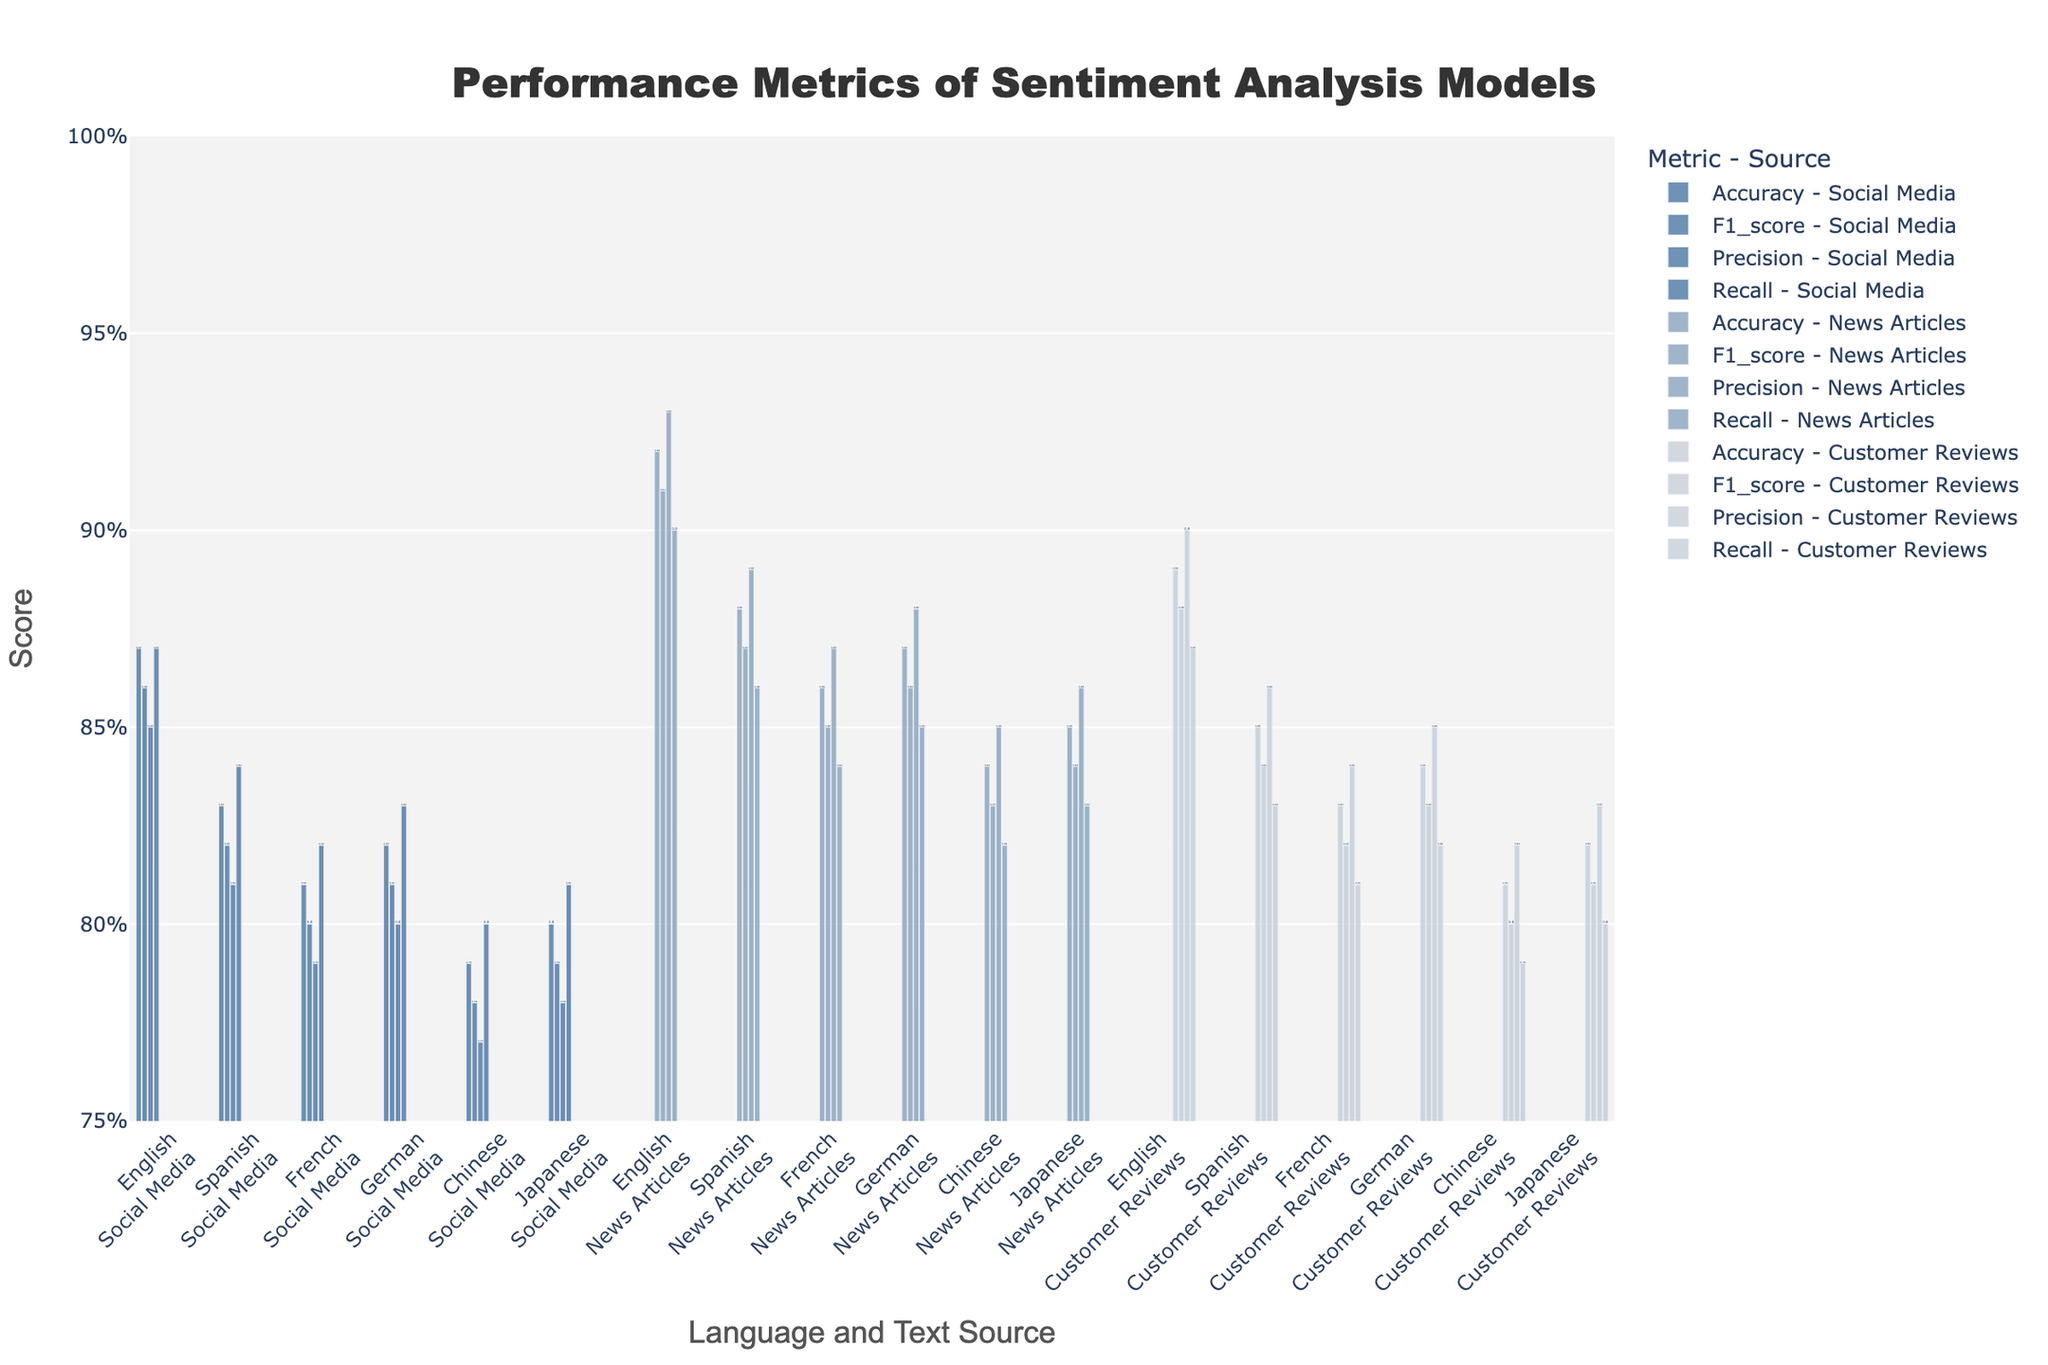Which language and text source combination has the highest accuracy? First, look for the highest values on the accuracy metric bars and then identify the corresponding language and text source. The highest bar corresponds to English, News Articles.
Answer: English, News Articles Compare the performance of sentiment analysis models in terms of F1_score across News Articles for English and Spanish. Which is higher? Focus on the F1_score bars for News Articles in English and Spanish. Compare the heights of these bars. The English News Articles bar is higher.
Answer: English How does the precision of the sentiment analysis model for French Customer Reviews compare to that of German Customer Reviews? Compare the heights of the precision metric bars for French Customer Reviews and German Customer Reviews. The bar height of German Customer Reviews is higher than that of French Customer Reviews.
Answer: German What is the average accuracy for Social Media across all languages? Sum the accuracy values for Social Media for all languages (0.87 + 0.83 + 0.81 + 0.82 + 0.79 + 0.80), then divide by the number of languages (6).
Answer: 0.82 Which language has the lowest recall in Social Media, and what is the value? Look for the lowest recall metric bar in the Social Media category and identify the language. The lowest bar is Chinese, with a value of 0.80.
Answer: Chinese, 0.80 Is the recall for Spanish Customer Reviews higher or lower compared to English Social Media? Compare the recall height for Spanish Customer Reviews and English Social Media. The recall for Spanish Customer Reviews (0.83) is lower than for English Social Media (0.87).
Answer: Lower What is the sum of the F1_scores for Japanese across all text sources? Add up the F1_scores for Japanese across Social Media, News Articles, and Customer Reviews (0.79 + 0.84 + 0.81).
Answer: 2.44 How does the average precision for sentiment analysis models on News Articles compare to the average precision on Customer Reviews across all languages? Calculate the average precision for News Articles (average of 0.93, 0.89, 0.87, 0.88, 0.85) and Customer Reviews (average of 0.90, 0.86, 0.84, 0.85, 0.82, 0.83), and compare these averages.
Answer: News Articles have a higher average precision 